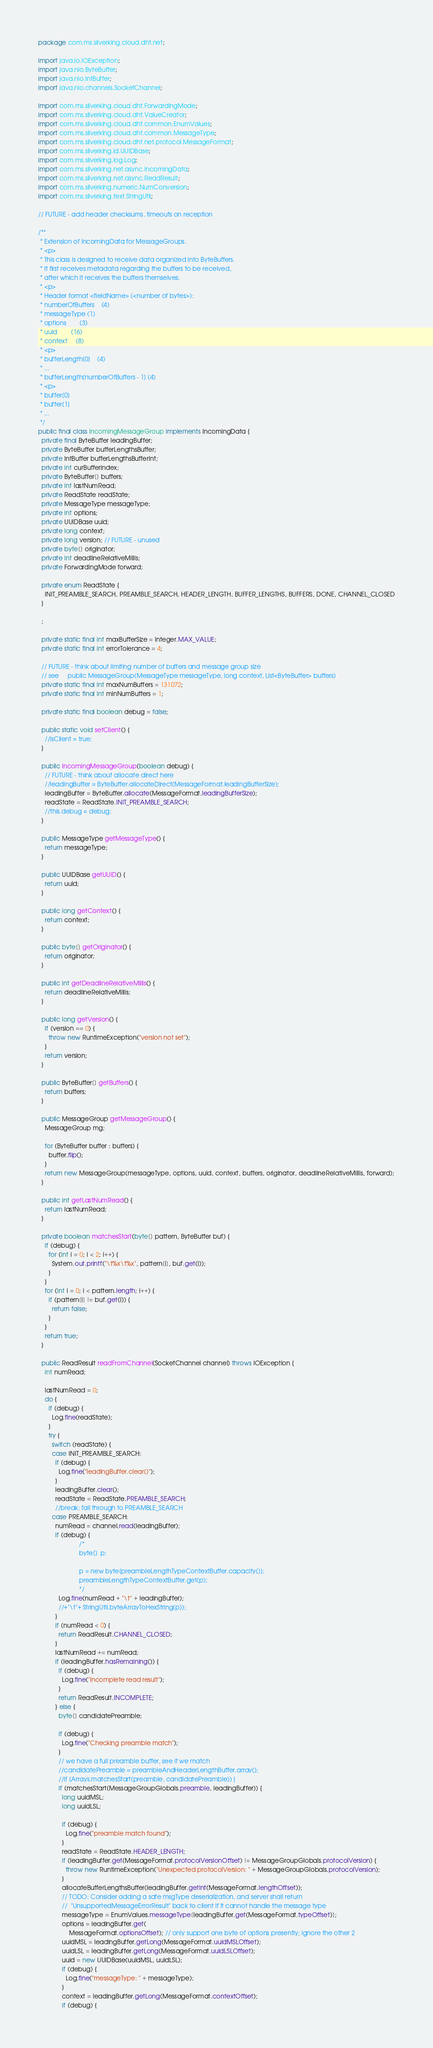<code> <loc_0><loc_0><loc_500><loc_500><_Java_>package com.ms.silverking.cloud.dht.net;

import java.io.IOException;
import java.nio.ByteBuffer;
import java.nio.IntBuffer;
import java.nio.channels.SocketChannel;

import com.ms.silverking.cloud.dht.ForwardingMode;
import com.ms.silverking.cloud.dht.ValueCreator;
import com.ms.silverking.cloud.dht.common.EnumValues;
import com.ms.silverking.cloud.dht.common.MessageType;
import com.ms.silverking.cloud.dht.net.protocol.MessageFormat;
import com.ms.silverking.id.UUIDBase;
import com.ms.silverking.log.Log;
import com.ms.silverking.net.async.IncomingData;
import com.ms.silverking.net.async.ReadResult;
import com.ms.silverking.numeric.NumConversion;
import com.ms.silverking.text.StringUtil;

// FUTURE - add header checksums, timeouts on reception

/**
 * Extension of IncomingData for MessageGroups.
 * <p>
 * This class is designed to receive data organized into ByteBuffers.
 * It first receives metadata regarding the buffers to be received,
 * after which it receives the buffers themselves.
 * <p>
 * Header format <fieldName> (<number of bytes>):
 * numberOfBuffers    (4)
 * messageType (1)
 * options        (3)
 * uuid        (16)
 * context     (8)
 * <p>
 * bufferLength[0]    (4)
 * ...
 * bufferLength[numberOfBuffers - 1] (4)
 * <p>
 * buffer[0]
 * buffer[1]
 * ...
 */
public final class IncomingMessageGroup implements IncomingData {
  private final ByteBuffer leadingBuffer;
  private ByteBuffer bufferLengthsBuffer;
  private IntBuffer bufferLengthsBufferInt;
  private int curBufferIndex;
  private ByteBuffer[] buffers;
  private int lastNumRead;
  private ReadState readState;
  private MessageType messageType;
  private int options;
  private UUIDBase uuid;
  private long context;
  private long version; // FUTURE - unused
  private byte[] originator;
  private int deadlineRelativeMillis;
  private ForwardingMode forward;

  private enum ReadState {
    INIT_PREAMBLE_SEARCH, PREAMBLE_SEARCH, HEADER_LENGTH, BUFFER_LENGTHS, BUFFERS, DONE, CHANNEL_CLOSED
  }

  ;

  private static final int maxBufferSize = Integer.MAX_VALUE;
  private static final int errorTolerance = 4;

  // FUTURE - think about limiting number of buffers and message group size
  // see     public MessageGroup(MessageType messageType, long context, List<ByteBuffer> buffers)
  private static final int maxNumBuffers = 131072;
  private static final int minNumBuffers = 1;

  private static final boolean debug = false;

  public static void setClient() {
    //isClient = true;
  }

  public IncomingMessageGroup(boolean debug) {
    // FUTURE - think about allocate direct here
    //leadingBuffer = ByteBuffer.allocateDirect(MessageFormat.leadingBufferSize);
    leadingBuffer = ByteBuffer.allocate(MessageFormat.leadingBufferSize);
    readState = ReadState.INIT_PREAMBLE_SEARCH;
    //this.debug = debug;
  }

  public MessageType getMessageType() {
    return messageType;
  }

  public UUIDBase getUUID() {
    return uuid;
  }

  public long getContext() {
    return context;
  }

  public byte[] getOriginator() {
    return originator;
  }

  public int getDeadlineRelativeMillis() {
    return deadlineRelativeMillis;
  }

  public long getVersion() {
    if (version == 0) {
      throw new RuntimeException("version not set");
    }
    return version;
  }

  public ByteBuffer[] getBuffers() {
    return buffers;
  }

  public MessageGroup getMessageGroup() {
    MessageGroup mg;

    for (ByteBuffer buffer : buffers) {
      buffer.flip();
    }
    return new MessageGroup(messageType, options, uuid, context, buffers, originator, deadlineRelativeMillis, forward);
  }

  public int getLastNumRead() {
    return lastNumRead;
  }

  private boolean matchesStart(byte[] pattern, ByteBuffer buf) {
    if (debug) {
      for (int i = 0; i < 2; i++) {
        System.out.printf("\t%x\t%x", pattern[i], buf.get(i));
      }
    }
    for (int i = 0; i < pattern.length; i++) {
      if (pattern[i] != buf.get(i)) {
        return false;
      }
    }
    return true;
  }

  public ReadResult readFromChannel(SocketChannel channel) throws IOException {
    int numRead;

    lastNumRead = 0;
    do {
      if (debug) {
        Log.fine(readState);
      }
      try {
        switch (readState) {
        case INIT_PREAMBLE_SEARCH:
          if (debug) {
            Log.fine("leadingBuffer.clear()");
          }
          leadingBuffer.clear();
          readState = ReadState.PREAMBLE_SEARCH;
          //break; fall through to PREAMBLE_SEARCH
        case PREAMBLE_SEARCH:
          numRead = channel.read(leadingBuffer);
          if (debug) {
                        /*
                        byte[]  p;
                        
                        p = new byte[preambleLengthTypeContextBuffer.capacity()];
                        preambleLengthTypeContextBuffer.get(p);
                        */
            Log.fine(numRead + "\t" + leadingBuffer);
            //+"\t"+ StringUtil.byteArrayToHexString(p));
          }
          if (numRead < 0) {
            return ReadResult.CHANNEL_CLOSED;
          }
          lastNumRead += numRead;
          if (leadingBuffer.hasRemaining()) {
            if (debug) {
              Log.fine("Incomplete read result");
            }
            return ReadResult.INCOMPLETE;
          } else {
            byte[] candidatePreamble;

            if (debug) {
              Log.fine("Checking preamble match");
            }
            // we have a full preamble buffer, see if we match
            //candidatePreamble = preambleAndHeaderLengthBuffer.array();
            //if (Arrays.matchesStart(preamble, candidatePreamble)) {
            if (matchesStart(MessageGroupGlobals.preamble, leadingBuffer)) {
              long uuidMSL;
              long uuidLSL;

              if (debug) {
                Log.fine("preamble match found");
              }
              readState = ReadState.HEADER_LENGTH;
              if (leadingBuffer.get(MessageFormat.protocolVersionOffset) != MessageGroupGlobals.protocolVersion) {
                throw new RuntimeException("Unexpected protocolVersion: " + MessageGroupGlobals.protocolVersion);
              }
              allocateBufferLengthsBuffer(leadingBuffer.getInt(MessageFormat.lengthOffset));
              // TODO: Consider adding a safe msgType deserialization, and server shall return
              //  "UnsupportedMessageErrorResult" back to client if it cannot handle the message type
              messageType = EnumValues.messageType[leadingBuffer.get(MessageFormat.typeOffset)];
              options = leadingBuffer.get(
                  MessageFormat.optionsOffset); // only support one byte of options presently; ignore the other 2
              uuidMSL = leadingBuffer.getLong(MessageFormat.uuidMSLOffset);
              uuidLSL = leadingBuffer.getLong(MessageFormat.uuidLSLOffset);
              uuid = new UUIDBase(uuidMSL, uuidLSL);
              if (debug) {
                Log.fine("messageType: " + messageType);
              }
              context = leadingBuffer.getLong(MessageFormat.contextOffset);
              if (debug) {</code> 